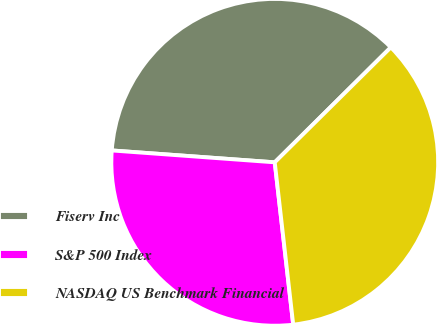Convert chart to OTSL. <chart><loc_0><loc_0><loc_500><loc_500><pie_chart><fcel>Fiserv Inc<fcel>S&P 500 Index<fcel>NASDAQ US Benchmark Financial<nl><fcel>36.42%<fcel>27.96%<fcel>35.62%<nl></chart> 